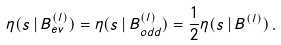Convert formula to latex. <formula><loc_0><loc_0><loc_500><loc_500>\eta ( s \, | \, B _ { e v } ^ { ( l ) } ) = \eta ( s \, | \, B _ { o d d } ^ { ( l ) } ) = \frac { 1 } { 2 } \eta ( s \, | \, B ^ { ( l ) } ) \, .</formula> 